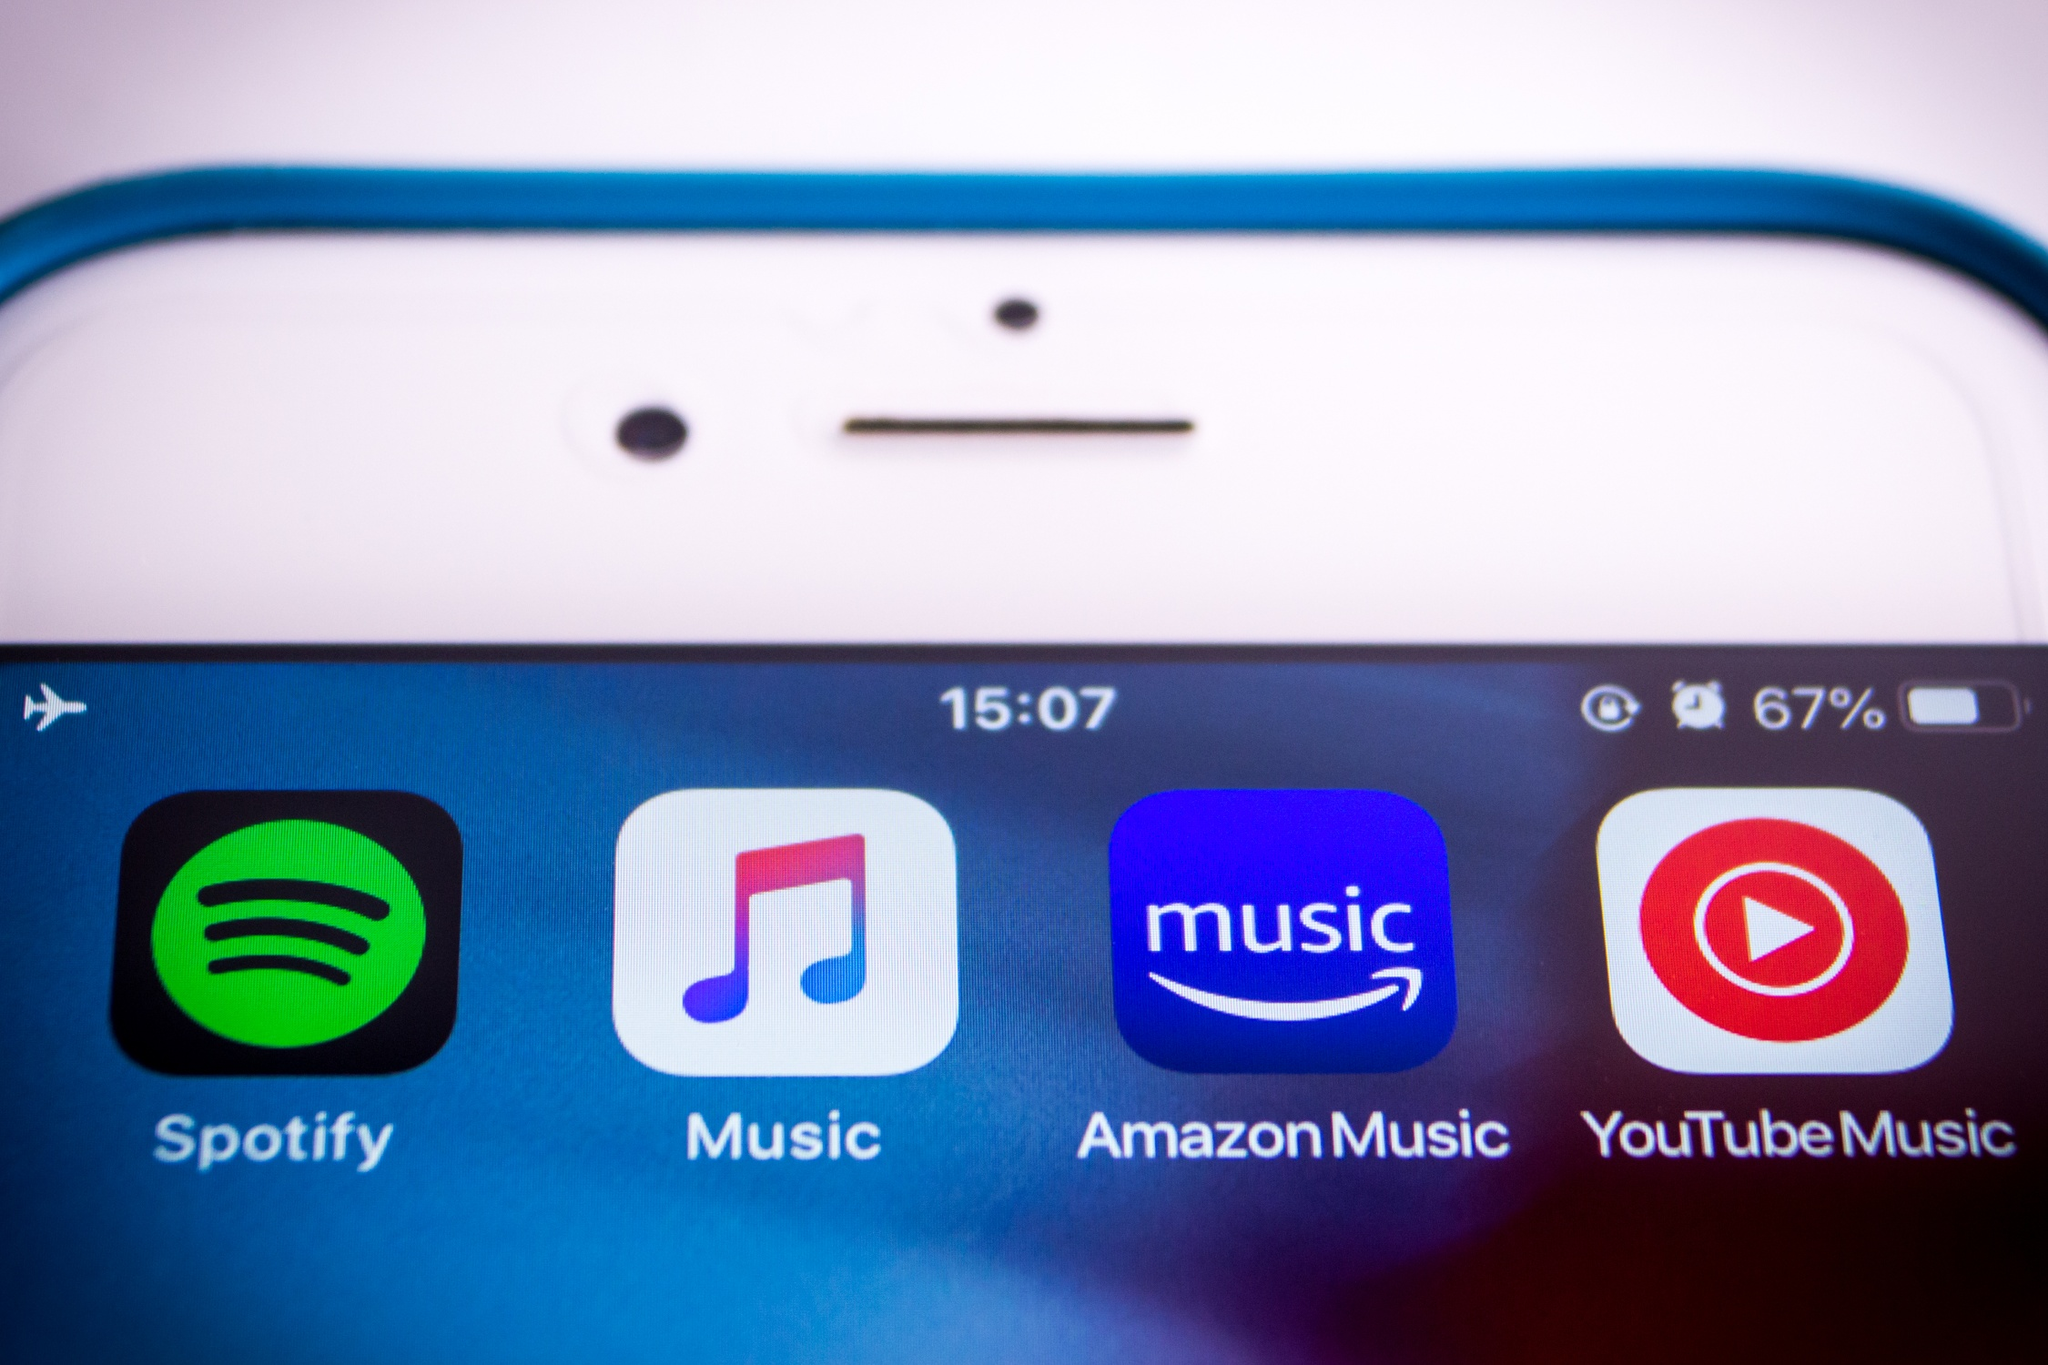Analyze the image in a comprehensive and detailed manner. The image offers a close-up view of a smartphone screen against a black backdrop. The phone, which is white and encased in a blue cover, has visible front-facing elements including a speaker and a camera at the top. The screen prominently displays four app icons in a row, each representing a different music streaming service. From left to right, these icons are for Spotify, denoted by its familiar green logo; Music, assumed to be Apple Music due to its note symbol on a white background; Amazon Music, identifiable by its orange logo; and YouTube Music, recognized by the red play button inside a white circle.

The status bar at the top shows the time as 15:07 and the battery level at 67%, likely indicating the phone's current operating status. The configuration of icons and the information on the status bar suggest that the phone is in a standby state, ready for interaction. The well-organized layout and clear iconography suggest a user-friendly interface, with text labels under each app icon aiding in the quick identification of each music service.

Overall, the image encapsulates a common modern scenario: a smartphone screen with various music streaming options, highlighting the variety and accessibility of digital music entertainment today. 